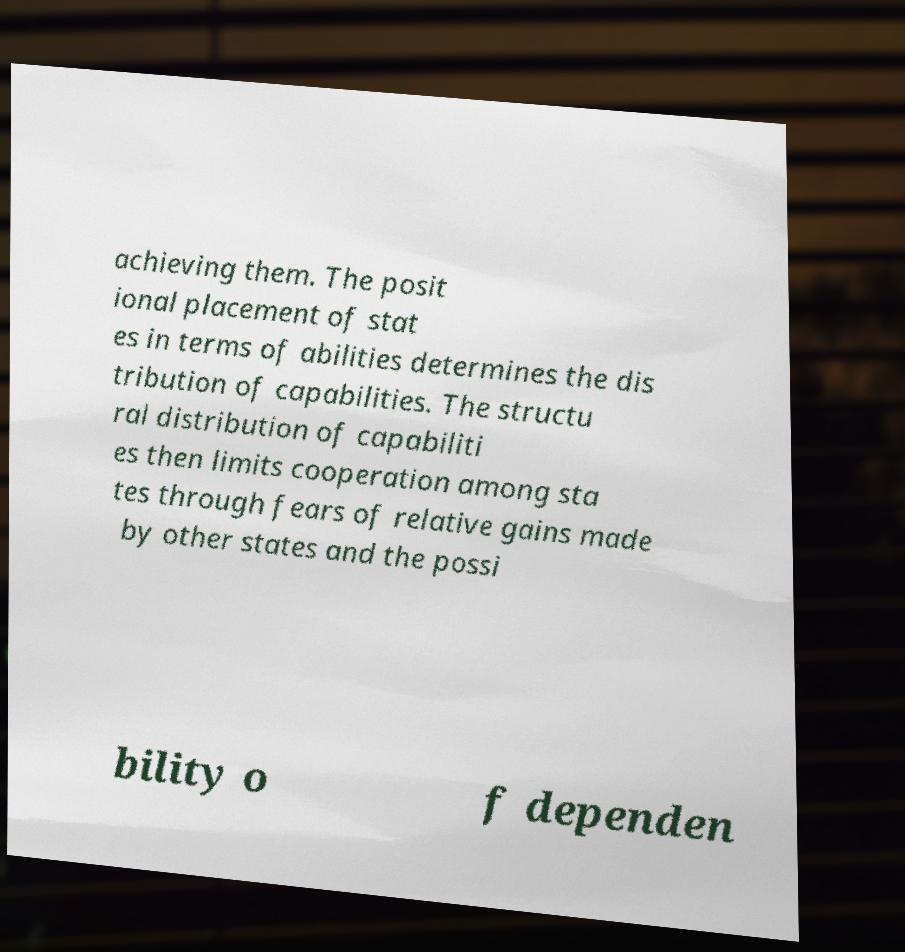Can you accurately transcribe the text from the provided image for me? achieving them. The posit ional placement of stat es in terms of abilities determines the dis tribution of capabilities. The structu ral distribution of capabiliti es then limits cooperation among sta tes through fears of relative gains made by other states and the possi bility o f dependen 